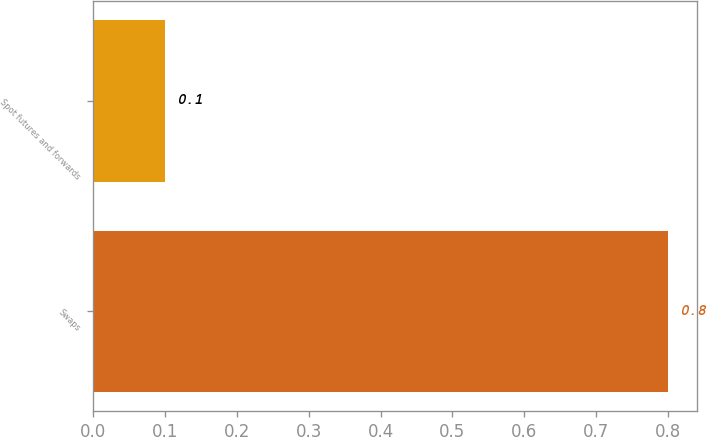Convert chart to OTSL. <chart><loc_0><loc_0><loc_500><loc_500><bar_chart><fcel>Swaps<fcel>Spot futures and forwards<nl><fcel>0.8<fcel>0.1<nl></chart> 